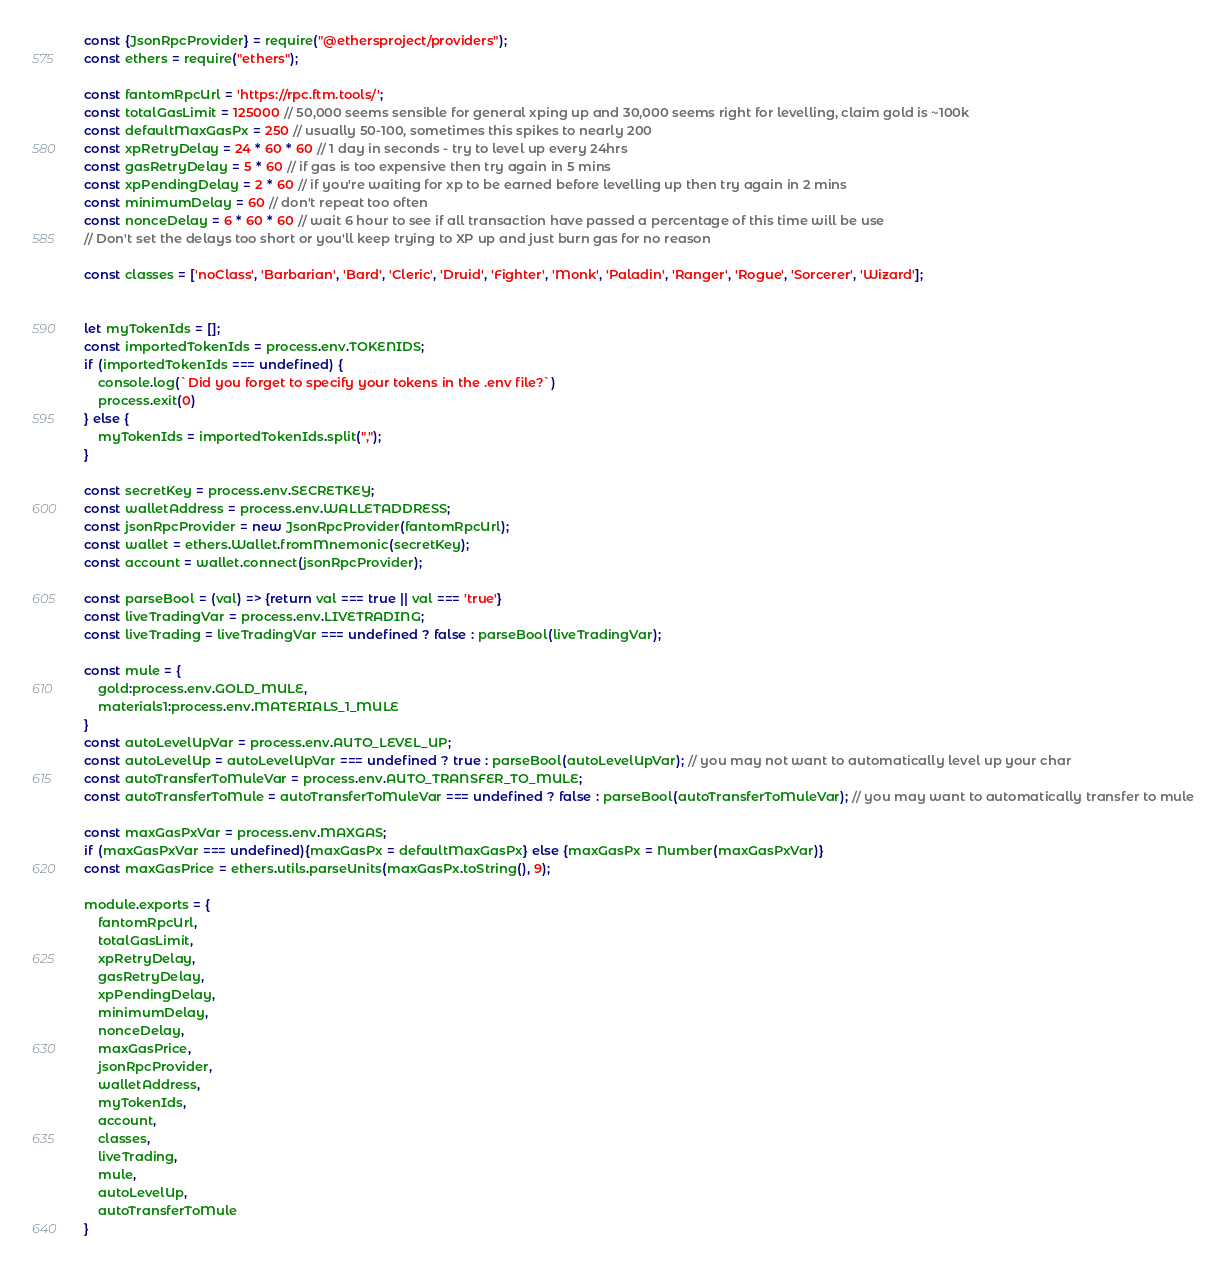Convert code to text. <code><loc_0><loc_0><loc_500><loc_500><_JavaScript_>const {JsonRpcProvider} = require("@ethersproject/providers");
const ethers = require("ethers");

const fantomRpcUrl = 'https://rpc.ftm.tools/';
const totalGasLimit = 125000 // 50,000 seems sensible for general xping up and 30,000 seems right for levelling, claim gold is ~100k
const defaultMaxGasPx = 250 // usually 50-100, sometimes this spikes to nearly 200
const xpRetryDelay = 24 * 60 * 60 // 1 day in seconds - try to level up every 24hrs
const gasRetryDelay = 5 * 60 // if gas is too expensive then try again in 5 mins
const xpPendingDelay = 2 * 60 // if you're waiting for xp to be earned before levelling up then try again in 2 mins
const minimumDelay = 60 // don't repeat too often
const nonceDelay = 6 * 60 * 60 // wait 6 hour to see if all transaction have passed a percentage of this time will be use
// Don't set the delays too short or you'll keep trying to XP up and just burn gas for no reason

const classes = ['noClass', 'Barbarian', 'Bard', 'Cleric', 'Druid', 'Fighter', 'Monk', 'Paladin', 'Ranger', 'Rogue', 'Sorcerer', 'Wizard'];


let myTokenIds = [];
const importedTokenIds = process.env.TOKENIDS;
if (importedTokenIds === undefined) {
    console.log(`Did you forget to specify your tokens in the .env file?`)
    process.exit(0)
} else {
    myTokenIds = importedTokenIds.split(",");
}

const secretKey = process.env.SECRETKEY;
const walletAddress = process.env.WALLETADDRESS;
const jsonRpcProvider = new JsonRpcProvider(fantomRpcUrl);
const wallet = ethers.Wallet.fromMnemonic(secretKey);
const account = wallet.connect(jsonRpcProvider);

const parseBool = (val) => {return val === true || val === 'true'}
const liveTradingVar = process.env.LIVETRADING;
const liveTrading = liveTradingVar === undefined ? false : parseBool(liveTradingVar);

const mule = {
    gold:process.env.GOLD_MULE,
    materials1:process.env.MATERIALS_1_MULE
}
const autoLevelUpVar = process.env.AUTO_LEVEL_UP;
const autoLevelUp = autoLevelUpVar === undefined ? true : parseBool(autoLevelUpVar); // you may not want to automatically level up your char
const autoTransferToMuleVar = process.env.AUTO_TRANSFER_TO_MULE;
const autoTransferToMule = autoTransferToMuleVar === undefined ? false : parseBool(autoTransferToMuleVar); // you may want to automatically transfer to mule

const maxGasPxVar = process.env.MAXGAS;
if (maxGasPxVar === undefined){maxGasPx = defaultMaxGasPx} else {maxGasPx = Number(maxGasPxVar)}
const maxGasPrice = ethers.utils.parseUnits(maxGasPx.toString(), 9);

module.exports = {
    fantomRpcUrl,
    totalGasLimit,
    xpRetryDelay,
    gasRetryDelay,
    xpPendingDelay,
    minimumDelay,
    nonceDelay,
    maxGasPrice,
    jsonRpcProvider,
    walletAddress,
    myTokenIds,
    account,
    classes,
    liveTrading,
    mule,
    autoLevelUp,
    autoTransferToMule
}</code> 